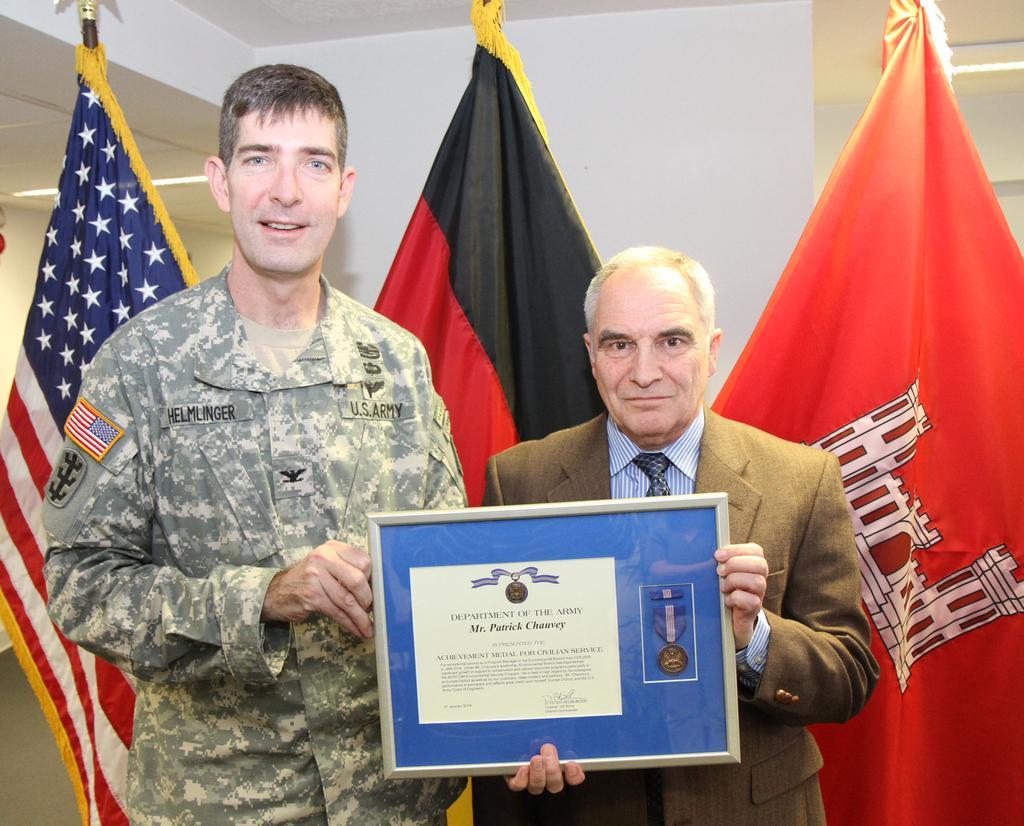Describe this image in one or two sentences. In this image I can see there are two persons holding a frame, back side of them I can see three flags and the wall. 